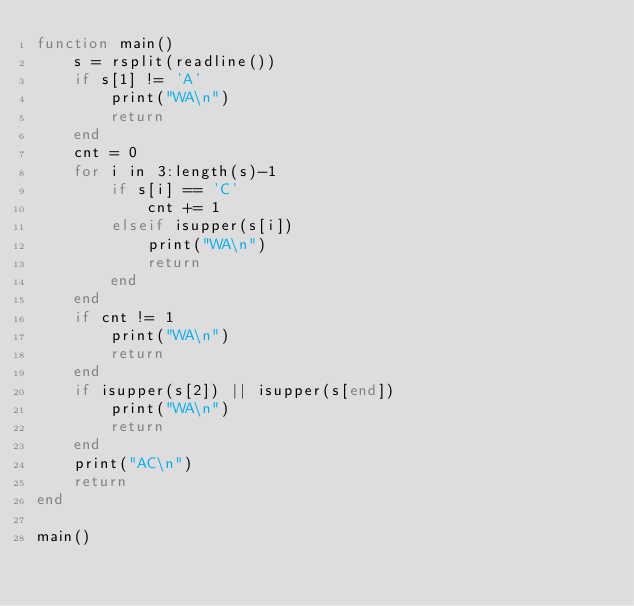<code> <loc_0><loc_0><loc_500><loc_500><_Julia_>function main()
    s = rsplit(readline())
    if s[1] != 'A'
        print("WA\n")
        return
    end
    cnt = 0
    for i in 3:length(s)-1
        if s[i] == 'C'
            cnt += 1
        elseif isupper(s[i])
            print("WA\n")
            return
        end
    end
    if cnt != 1
        print("WA\n")
        return
    end
    if isupper(s[2]) || isupper(s[end])
        print("WA\n")
        return
    end
    print("AC\n")
    return
end

main()
</code> 